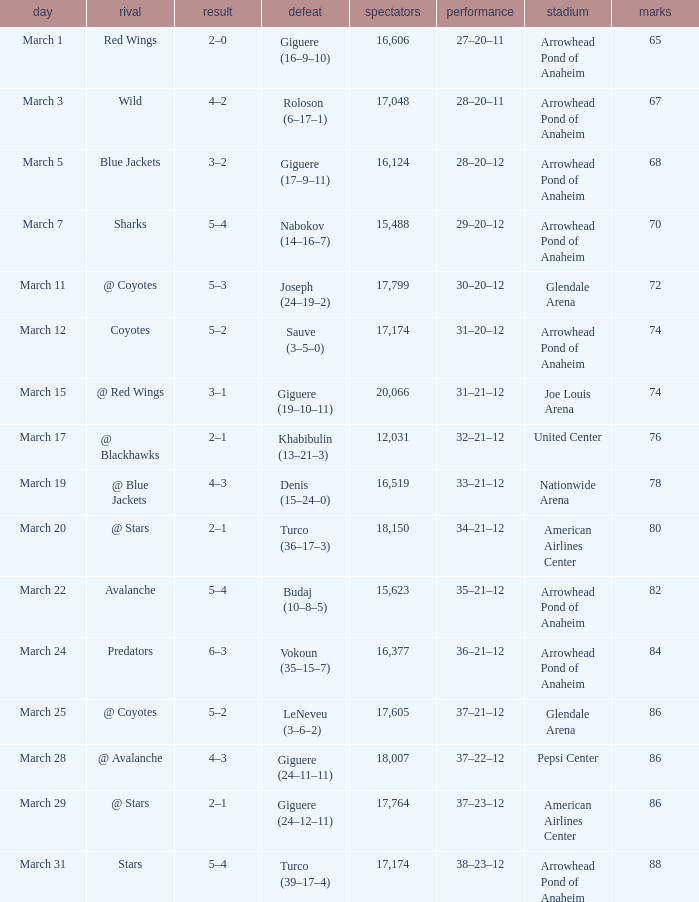What is the Attendance at Joe Louis Arena? 20066.0. 